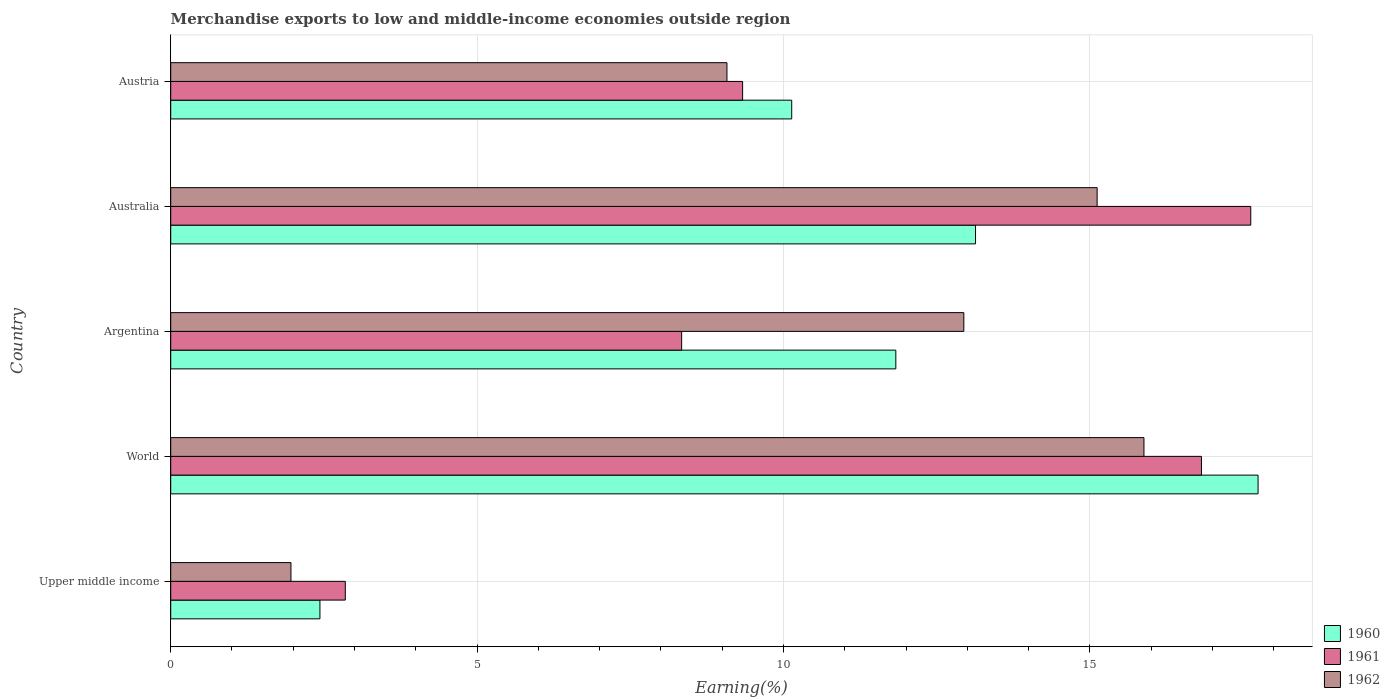How many different coloured bars are there?
Your answer should be compact. 3. How many groups of bars are there?
Give a very brief answer. 5. What is the label of the 1st group of bars from the top?
Provide a short and direct response. Austria. What is the percentage of amount earned from merchandise exports in 1962 in Upper middle income?
Your answer should be very brief. 1.96. Across all countries, what is the maximum percentage of amount earned from merchandise exports in 1962?
Offer a very short reply. 15.88. Across all countries, what is the minimum percentage of amount earned from merchandise exports in 1960?
Provide a succinct answer. 2.44. In which country was the percentage of amount earned from merchandise exports in 1962 minimum?
Your response must be concise. Upper middle income. What is the total percentage of amount earned from merchandise exports in 1962 in the graph?
Make the answer very short. 54.99. What is the difference between the percentage of amount earned from merchandise exports in 1961 in Argentina and that in Austria?
Provide a short and direct response. -0.99. What is the difference between the percentage of amount earned from merchandise exports in 1961 in Argentina and the percentage of amount earned from merchandise exports in 1960 in World?
Your answer should be very brief. -9.41. What is the average percentage of amount earned from merchandise exports in 1961 per country?
Your response must be concise. 10.99. What is the difference between the percentage of amount earned from merchandise exports in 1961 and percentage of amount earned from merchandise exports in 1960 in Australia?
Your answer should be compact. 4.49. In how many countries, is the percentage of amount earned from merchandise exports in 1961 greater than 9 %?
Give a very brief answer. 3. What is the ratio of the percentage of amount earned from merchandise exports in 1961 in Australia to that in Austria?
Provide a succinct answer. 1.89. Is the percentage of amount earned from merchandise exports in 1960 in Argentina less than that in Australia?
Give a very brief answer. Yes. Is the difference between the percentage of amount earned from merchandise exports in 1961 in Australia and Austria greater than the difference between the percentage of amount earned from merchandise exports in 1960 in Australia and Austria?
Your answer should be very brief. Yes. What is the difference between the highest and the second highest percentage of amount earned from merchandise exports in 1962?
Offer a very short reply. 0.76. What is the difference between the highest and the lowest percentage of amount earned from merchandise exports in 1962?
Your response must be concise. 13.92. In how many countries, is the percentage of amount earned from merchandise exports in 1961 greater than the average percentage of amount earned from merchandise exports in 1961 taken over all countries?
Provide a short and direct response. 2. Is the sum of the percentage of amount earned from merchandise exports in 1962 in Argentina and Australia greater than the maximum percentage of amount earned from merchandise exports in 1961 across all countries?
Keep it short and to the point. Yes. What does the 3rd bar from the top in Upper middle income represents?
Provide a succinct answer. 1960. How many countries are there in the graph?
Provide a short and direct response. 5. What is the difference between two consecutive major ticks on the X-axis?
Ensure brevity in your answer.  5. Are the values on the major ticks of X-axis written in scientific E-notation?
Your answer should be compact. No. What is the title of the graph?
Ensure brevity in your answer.  Merchandise exports to low and middle-income economies outside region. Does "2012" appear as one of the legend labels in the graph?
Give a very brief answer. No. What is the label or title of the X-axis?
Provide a short and direct response. Earning(%). What is the Earning(%) in 1960 in Upper middle income?
Give a very brief answer. 2.44. What is the Earning(%) in 1961 in Upper middle income?
Provide a succinct answer. 2.85. What is the Earning(%) in 1962 in Upper middle income?
Offer a very short reply. 1.96. What is the Earning(%) of 1960 in World?
Your response must be concise. 17.75. What is the Earning(%) of 1961 in World?
Your answer should be very brief. 16.82. What is the Earning(%) of 1962 in World?
Provide a succinct answer. 15.88. What is the Earning(%) in 1960 in Argentina?
Ensure brevity in your answer.  11.83. What is the Earning(%) in 1961 in Argentina?
Provide a succinct answer. 8.34. What is the Earning(%) of 1962 in Argentina?
Keep it short and to the point. 12.94. What is the Earning(%) in 1960 in Australia?
Give a very brief answer. 13.13. What is the Earning(%) of 1961 in Australia?
Your answer should be very brief. 17.63. What is the Earning(%) in 1962 in Australia?
Give a very brief answer. 15.12. What is the Earning(%) of 1960 in Austria?
Your response must be concise. 10.13. What is the Earning(%) in 1961 in Austria?
Offer a very short reply. 9.33. What is the Earning(%) of 1962 in Austria?
Ensure brevity in your answer.  9.08. Across all countries, what is the maximum Earning(%) in 1960?
Keep it short and to the point. 17.75. Across all countries, what is the maximum Earning(%) in 1961?
Offer a very short reply. 17.63. Across all countries, what is the maximum Earning(%) of 1962?
Keep it short and to the point. 15.88. Across all countries, what is the minimum Earning(%) of 1960?
Offer a terse response. 2.44. Across all countries, what is the minimum Earning(%) of 1961?
Offer a terse response. 2.85. Across all countries, what is the minimum Earning(%) of 1962?
Your response must be concise. 1.96. What is the total Earning(%) in 1960 in the graph?
Your answer should be very brief. 55.28. What is the total Earning(%) in 1961 in the graph?
Your answer should be very brief. 54.97. What is the total Earning(%) of 1962 in the graph?
Offer a terse response. 54.99. What is the difference between the Earning(%) in 1960 in Upper middle income and that in World?
Provide a short and direct response. -15.31. What is the difference between the Earning(%) in 1961 in Upper middle income and that in World?
Keep it short and to the point. -13.97. What is the difference between the Earning(%) in 1962 in Upper middle income and that in World?
Your answer should be compact. -13.92. What is the difference between the Earning(%) in 1960 in Upper middle income and that in Argentina?
Offer a terse response. -9.4. What is the difference between the Earning(%) in 1961 in Upper middle income and that in Argentina?
Your response must be concise. -5.49. What is the difference between the Earning(%) in 1962 in Upper middle income and that in Argentina?
Keep it short and to the point. -10.98. What is the difference between the Earning(%) of 1960 in Upper middle income and that in Australia?
Provide a succinct answer. -10.7. What is the difference between the Earning(%) in 1961 in Upper middle income and that in Australia?
Provide a short and direct response. -14.78. What is the difference between the Earning(%) of 1962 in Upper middle income and that in Australia?
Give a very brief answer. -13.16. What is the difference between the Earning(%) of 1960 in Upper middle income and that in Austria?
Provide a succinct answer. -7.7. What is the difference between the Earning(%) of 1961 in Upper middle income and that in Austria?
Your answer should be very brief. -6.48. What is the difference between the Earning(%) of 1962 in Upper middle income and that in Austria?
Ensure brevity in your answer.  -7.12. What is the difference between the Earning(%) in 1960 in World and that in Argentina?
Your answer should be compact. 5.91. What is the difference between the Earning(%) in 1961 in World and that in Argentina?
Your answer should be compact. 8.48. What is the difference between the Earning(%) in 1962 in World and that in Argentina?
Provide a succinct answer. 2.94. What is the difference between the Earning(%) in 1960 in World and that in Australia?
Ensure brevity in your answer.  4.61. What is the difference between the Earning(%) of 1961 in World and that in Australia?
Provide a succinct answer. -0.8. What is the difference between the Earning(%) in 1962 in World and that in Australia?
Provide a short and direct response. 0.76. What is the difference between the Earning(%) of 1960 in World and that in Austria?
Offer a terse response. 7.61. What is the difference between the Earning(%) of 1961 in World and that in Austria?
Provide a short and direct response. 7.49. What is the difference between the Earning(%) in 1962 in World and that in Austria?
Offer a terse response. 6.81. What is the difference between the Earning(%) of 1960 in Argentina and that in Australia?
Offer a very short reply. -1.3. What is the difference between the Earning(%) in 1961 in Argentina and that in Australia?
Give a very brief answer. -9.29. What is the difference between the Earning(%) of 1962 in Argentina and that in Australia?
Make the answer very short. -2.18. What is the difference between the Earning(%) in 1960 in Argentina and that in Austria?
Your answer should be compact. 1.7. What is the difference between the Earning(%) in 1961 in Argentina and that in Austria?
Your answer should be compact. -0.99. What is the difference between the Earning(%) in 1962 in Argentina and that in Austria?
Provide a short and direct response. 3.87. What is the difference between the Earning(%) of 1960 in Australia and that in Austria?
Your response must be concise. 3. What is the difference between the Earning(%) in 1961 in Australia and that in Austria?
Provide a succinct answer. 8.29. What is the difference between the Earning(%) of 1962 in Australia and that in Austria?
Offer a terse response. 6.04. What is the difference between the Earning(%) of 1960 in Upper middle income and the Earning(%) of 1961 in World?
Your response must be concise. -14.39. What is the difference between the Earning(%) of 1960 in Upper middle income and the Earning(%) of 1962 in World?
Offer a very short reply. -13.45. What is the difference between the Earning(%) of 1961 in Upper middle income and the Earning(%) of 1962 in World?
Keep it short and to the point. -13.03. What is the difference between the Earning(%) of 1960 in Upper middle income and the Earning(%) of 1961 in Argentina?
Make the answer very short. -5.9. What is the difference between the Earning(%) in 1960 in Upper middle income and the Earning(%) in 1962 in Argentina?
Your response must be concise. -10.51. What is the difference between the Earning(%) in 1961 in Upper middle income and the Earning(%) in 1962 in Argentina?
Offer a terse response. -10.09. What is the difference between the Earning(%) in 1960 in Upper middle income and the Earning(%) in 1961 in Australia?
Keep it short and to the point. -15.19. What is the difference between the Earning(%) of 1960 in Upper middle income and the Earning(%) of 1962 in Australia?
Keep it short and to the point. -12.68. What is the difference between the Earning(%) of 1961 in Upper middle income and the Earning(%) of 1962 in Australia?
Offer a terse response. -12.27. What is the difference between the Earning(%) of 1960 in Upper middle income and the Earning(%) of 1961 in Austria?
Your response must be concise. -6.9. What is the difference between the Earning(%) of 1960 in Upper middle income and the Earning(%) of 1962 in Austria?
Provide a succinct answer. -6.64. What is the difference between the Earning(%) of 1961 in Upper middle income and the Earning(%) of 1962 in Austria?
Provide a succinct answer. -6.23. What is the difference between the Earning(%) in 1960 in World and the Earning(%) in 1961 in Argentina?
Give a very brief answer. 9.41. What is the difference between the Earning(%) of 1960 in World and the Earning(%) of 1962 in Argentina?
Your response must be concise. 4.8. What is the difference between the Earning(%) in 1961 in World and the Earning(%) in 1962 in Argentina?
Make the answer very short. 3.88. What is the difference between the Earning(%) of 1960 in World and the Earning(%) of 1961 in Australia?
Provide a succinct answer. 0.12. What is the difference between the Earning(%) of 1960 in World and the Earning(%) of 1962 in Australia?
Offer a very short reply. 2.63. What is the difference between the Earning(%) in 1961 in World and the Earning(%) in 1962 in Australia?
Offer a very short reply. 1.7. What is the difference between the Earning(%) of 1960 in World and the Earning(%) of 1961 in Austria?
Give a very brief answer. 8.41. What is the difference between the Earning(%) in 1960 in World and the Earning(%) in 1962 in Austria?
Provide a short and direct response. 8.67. What is the difference between the Earning(%) in 1961 in World and the Earning(%) in 1962 in Austria?
Offer a terse response. 7.74. What is the difference between the Earning(%) in 1960 in Argentina and the Earning(%) in 1961 in Australia?
Your answer should be very brief. -5.79. What is the difference between the Earning(%) of 1960 in Argentina and the Earning(%) of 1962 in Australia?
Keep it short and to the point. -3.29. What is the difference between the Earning(%) of 1961 in Argentina and the Earning(%) of 1962 in Australia?
Provide a short and direct response. -6.78. What is the difference between the Earning(%) in 1960 in Argentina and the Earning(%) in 1961 in Austria?
Provide a short and direct response. 2.5. What is the difference between the Earning(%) in 1960 in Argentina and the Earning(%) in 1962 in Austria?
Offer a very short reply. 2.76. What is the difference between the Earning(%) in 1961 in Argentina and the Earning(%) in 1962 in Austria?
Your answer should be very brief. -0.74. What is the difference between the Earning(%) in 1960 in Australia and the Earning(%) in 1961 in Austria?
Your response must be concise. 3.8. What is the difference between the Earning(%) in 1960 in Australia and the Earning(%) in 1962 in Austria?
Ensure brevity in your answer.  4.06. What is the difference between the Earning(%) of 1961 in Australia and the Earning(%) of 1962 in Austria?
Your answer should be compact. 8.55. What is the average Earning(%) in 1960 per country?
Give a very brief answer. 11.06. What is the average Earning(%) in 1961 per country?
Give a very brief answer. 10.99. What is the average Earning(%) of 1962 per country?
Offer a very short reply. 11. What is the difference between the Earning(%) in 1960 and Earning(%) in 1961 in Upper middle income?
Your response must be concise. -0.41. What is the difference between the Earning(%) in 1960 and Earning(%) in 1962 in Upper middle income?
Make the answer very short. 0.47. What is the difference between the Earning(%) of 1961 and Earning(%) of 1962 in Upper middle income?
Your answer should be very brief. 0.89. What is the difference between the Earning(%) in 1960 and Earning(%) in 1961 in World?
Provide a succinct answer. 0.92. What is the difference between the Earning(%) in 1960 and Earning(%) in 1962 in World?
Your answer should be compact. 1.86. What is the difference between the Earning(%) in 1961 and Earning(%) in 1962 in World?
Your response must be concise. 0.94. What is the difference between the Earning(%) in 1960 and Earning(%) in 1961 in Argentina?
Keep it short and to the point. 3.5. What is the difference between the Earning(%) of 1960 and Earning(%) of 1962 in Argentina?
Offer a terse response. -1.11. What is the difference between the Earning(%) of 1961 and Earning(%) of 1962 in Argentina?
Offer a terse response. -4.61. What is the difference between the Earning(%) of 1960 and Earning(%) of 1961 in Australia?
Your answer should be very brief. -4.49. What is the difference between the Earning(%) in 1960 and Earning(%) in 1962 in Australia?
Provide a succinct answer. -1.98. What is the difference between the Earning(%) of 1961 and Earning(%) of 1962 in Australia?
Provide a short and direct response. 2.51. What is the difference between the Earning(%) of 1960 and Earning(%) of 1961 in Austria?
Ensure brevity in your answer.  0.8. What is the difference between the Earning(%) in 1960 and Earning(%) in 1962 in Austria?
Offer a very short reply. 1.06. What is the difference between the Earning(%) in 1961 and Earning(%) in 1962 in Austria?
Your answer should be very brief. 0.26. What is the ratio of the Earning(%) in 1960 in Upper middle income to that in World?
Your answer should be compact. 0.14. What is the ratio of the Earning(%) in 1961 in Upper middle income to that in World?
Ensure brevity in your answer.  0.17. What is the ratio of the Earning(%) of 1962 in Upper middle income to that in World?
Ensure brevity in your answer.  0.12. What is the ratio of the Earning(%) of 1960 in Upper middle income to that in Argentina?
Make the answer very short. 0.21. What is the ratio of the Earning(%) in 1961 in Upper middle income to that in Argentina?
Provide a succinct answer. 0.34. What is the ratio of the Earning(%) in 1962 in Upper middle income to that in Argentina?
Your response must be concise. 0.15. What is the ratio of the Earning(%) in 1960 in Upper middle income to that in Australia?
Keep it short and to the point. 0.19. What is the ratio of the Earning(%) of 1961 in Upper middle income to that in Australia?
Offer a very short reply. 0.16. What is the ratio of the Earning(%) of 1962 in Upper middle income to that in Australia?
Your answer should be compact. 0.13. What is the ratio of the Earning(%) of 1960 in Upper middle income to that in Austria?
Provide a succinct answer. 0.24. What is the ratio of the Earning(%) in 1961 in Upper middle income to that in Austria?
Your response must be concise. 0.31. What is the ratio of the Earning(%) of 1962 in Upper middle income to that in Austria?
Your response must be concise. 0.22. What is the ratio of the Earning(%) in 1960 in World to that in Argentina?
Offer a very short reply. 1.5. What is the ratio of the Earning(%) in 1961 in World to that in Argentina?
Keep it short and to the point. 2.02. What is the ratio of the Earning(%) in 1962 in World to that in Argentina?
Offer a very short reply. 1.23. What is the ratio of the Earning(%) in 1960 in World to that in Australia?
Provide a short and direct response. 1.35. What is the ratio of the Earning(%) of 1961 in World to that in Australia?
Offer a very short reply. 0.95. What is the ratio of the Earning(%) of 1962 in World to that in Australia?
Give a very brief answer. 1.05. What is the ratio of the Earning(%) of 1960 in World to that in Austria?
Offer a terse response. 1.75. What is the ratio of the Earning(%) in 1961 in World to that in Austria?
Make the answer very short. 1.8. What is the ratio of the Earning(%) in 1962 in World to that in Austria?
Offer a very short reply. 1.75. What is the ratio of the Earning(%) of 1960 in Argentina to that in Australia?
Make the answer very short. 0.9. What is the ratio of the Earning(%) of 1961 in Argentina to that in Australia?
Ensure brevity in your answer.  0.47. What is the ratio of the Earning(%) of 1962 in Argentina to that in Australia?
Ensure brevity in your answer.  0.86. What is the ratio of the Earning(%) of 1960 in Argentina to that in Austria?
Ensure brevity in your answer.  1.17. What is the ratio of the Earning(%) of 1961 in Argentina to that in Austria?
Your response must be concise. 0.89. What is the ratio of the Earning(%) of 1962 in Argentina to that in Austria?
Your answer should be very brief. 1.43. What is the ratio of the Earning(%) of 1960 in Australia to that in Austria?
Your response must be concise. 1.3. What is the ratio of the Earning(%) of 1961 in Australia to that in Austria?
Give a very brief answer. 1.89. What is the ratio of the Earning(%) in 1962 in Australia to that in Austria?
Provide a succinct answer. 1.67. What is the difference between the highest and the second highest Earning(%) of 1960?
Make the answer very short. 4.61. What is the difference between the highest and the second highest Earning(%) in 1961?
Ensure brevity in your answer.  0.8. What is the difference between the highest and the second highest Earning(%) in 1962?
Provide a succinct answer. 0.76. What is the difference between the highest and the lowest Earning(%) of 1960?
Provide a succinct answer. 15.31. What is the difference between the highest and the lowest Earning(%) in 1961?
Make the answer very short. 14.78. What is the difference between the highest and the lowest Earning(%) of 1962?
Ensure brevity in your answer.  13.92. 